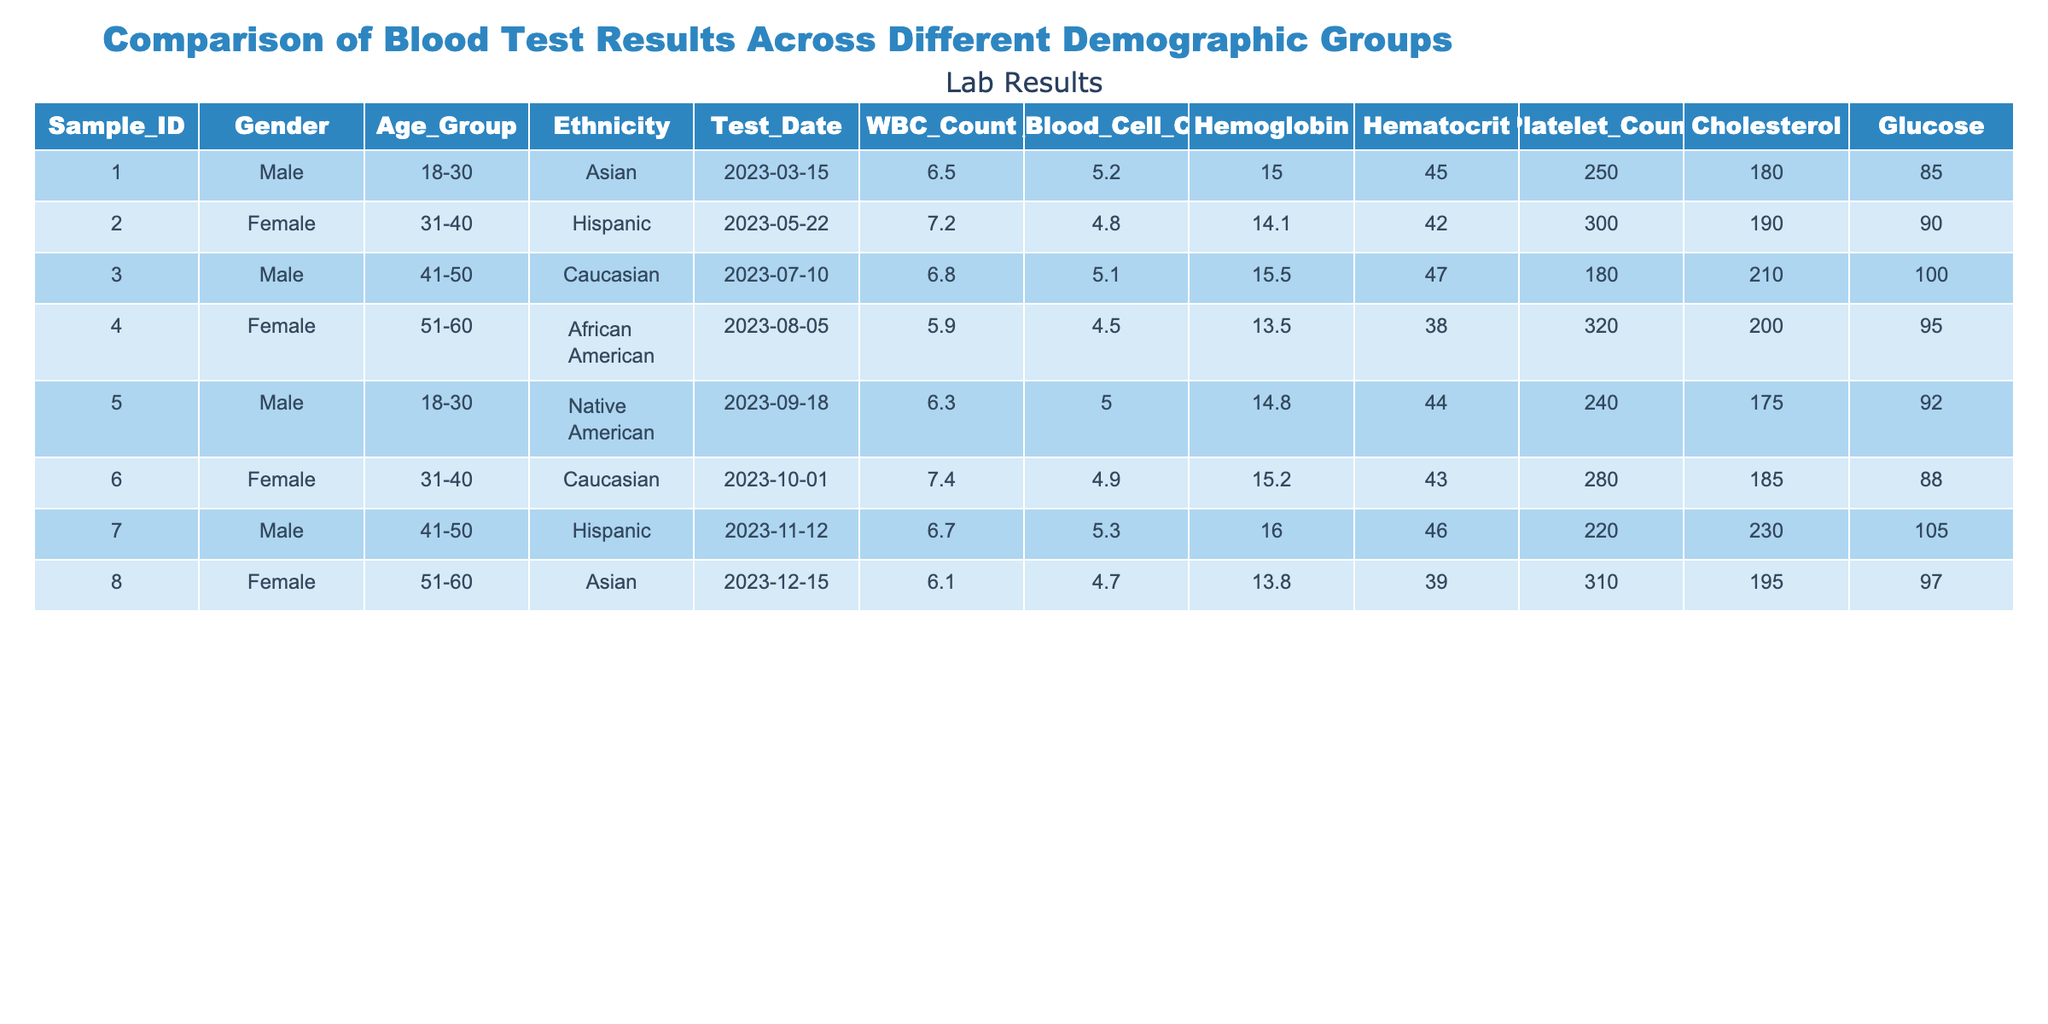What is the WBC count for the female patient in the 31-40 age group? The female patient in the 31-40 age group is Sample_ID 002. Referring to the table, her WBC Count is listed as 7.2.
Answer: 7.2 What is the average Hemoglobin level for male patients in the table? There are three male patients: Sample_IDs 001, 003, and 005 with Hemoglobin levels of 15.0, 15.5, and 14.8 respectively. The average is calculated as (15.0 + 15.5 + 14.8) / 3 = 15.1.
Answer: 15.1 Is there a female patient with a Platelet Count above 300? Looking at the table, the female patients are Sample_IDs 002, 004, 006, and 008. Their Platelet Counts are 300, 320, 280, and 310. Since 320 is above 300, there is a female patient that meets this criterion.
Answer: Yes What is the difference between the highest and lowest Cholesterol levels among the patients? Examining the Cholesterol values for all patients: 180, 190, 210, 200, 175, 185, 230, and 195. The highest value is 230 and the lowest is 175. Therefore, the difference is 230 - 175 = 55.
Answer: 55 What is the mean value of Hematocrit for the age group 51-60? There are two patients in the age group 51-60: Sample_IDs 004 and 008, with Hematocrit values of 38.0 and 39.0. The mean is (38.0 + 39.0) / 2 = 38.5.
Answer: 38.5 Is the Glucose level for the male patient in the 41-50 age group higher than 100? The male patient in the 41-50 age group is Sample_ID 003 with a Glucose level of 100. Since 100 is not higher than 100, the answer is no.
Answer: No Which ethnic group has the highest average WBC Count? The WBC Counts for each ethnic group are: Asian (Sample_IDs 001 and 008) with an average of (6.5 + 6.1) / 2 = 6.3; Hispanic (Sample_IDs 002 and 007) with an average of (7.2 + 6.7) / 2 = 6.95; Caucasian (3 patients) with (6.8 + 7.4) / 2 = 7.1; African American with 5.9; and Native American with 6.3. The highest average is for the Hispanic group at 6.95.
Answer: Hispanic What is the total Red Blood Cell Count for all patients combined? Adding the Red Blood Cell Counts together: 5.2 + 4.8 + 5.1 + 4.5 + 5.0 + 4.9 + 5.3 + 4.7 = 39.5.
Answer: 39.5 